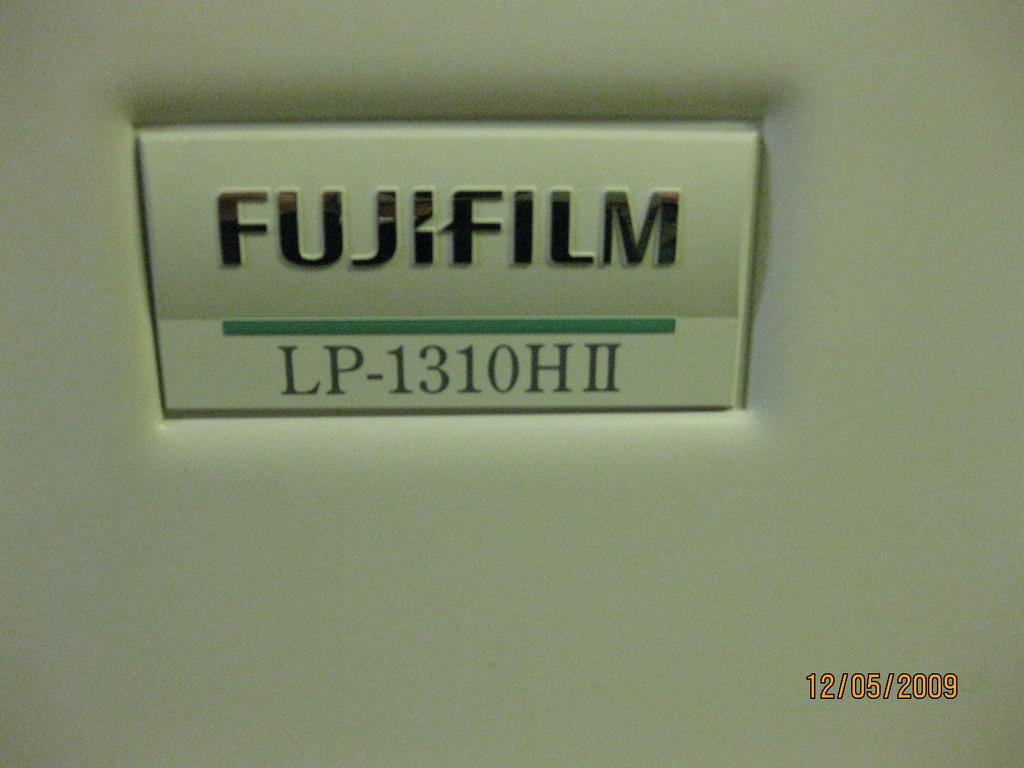How would you summarize this image in a sentence or two? In this image I can see a white color object, on the object I can see something written on it. 